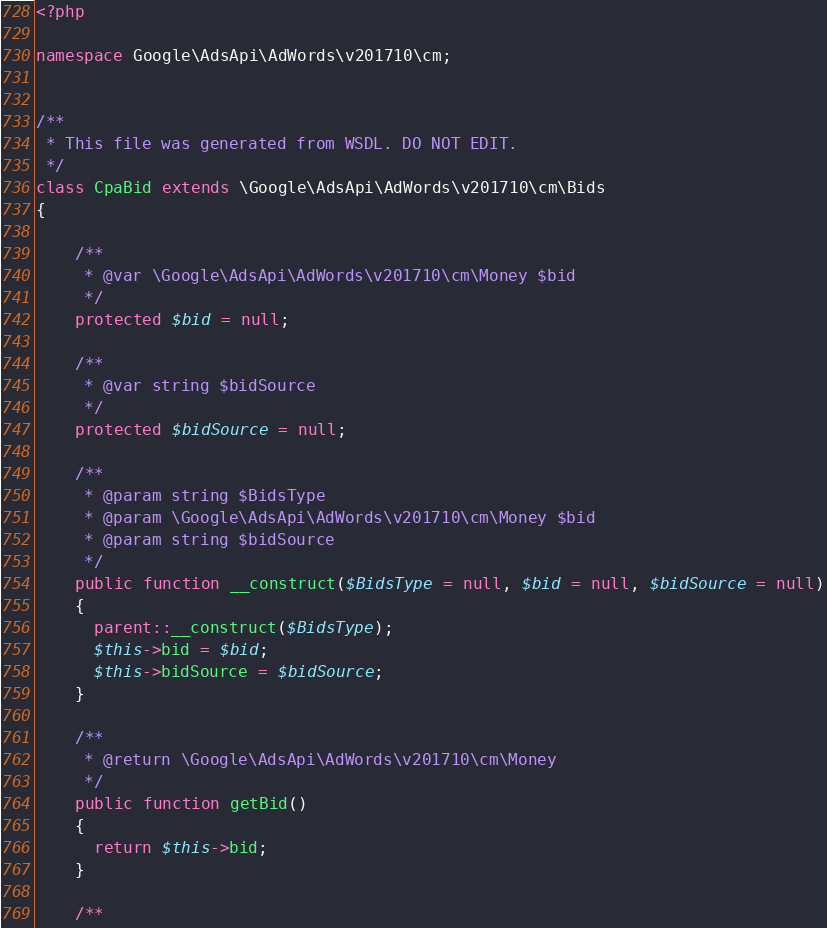Convert code to text. <code><loc_0><loc_0><loc_500><loc_500><_PHP_><?php

namespace Google\AdsApi\AdWords\v201710\cm;


/**
 * This file was generated from WSDL. DO NOT EDIT.
 */
class CpaBid extends \Google\AdsApi\AdWords\v201710\cm\Bids
{

    /**
     * @var \Google\AdsApi\AdWords\v201710\cm\Money $bid
     */
    protected $bid = null;

    /**
     * @var string $bidSource
     */
    protected $bidSource = null;

    /**
     * @param string $BidsType
     * @param \Google\AdsApi\AdWords\v201710\cm\Money $bid
     * @param string $bidSource
     */
    public function __construct($BidsType = null, $bid = null, $bidSource = null)
    {
      parent::__construct($BidsType);
      $this->bid = $bid;
      $this->bidSource = $bidSource;
    }

    /**
     * @return \Google\AdsApi\AdWords\v201710\cm\Money
     */
    public function getBid()
    {
      return $this->bid;
    }

    /**</code> 